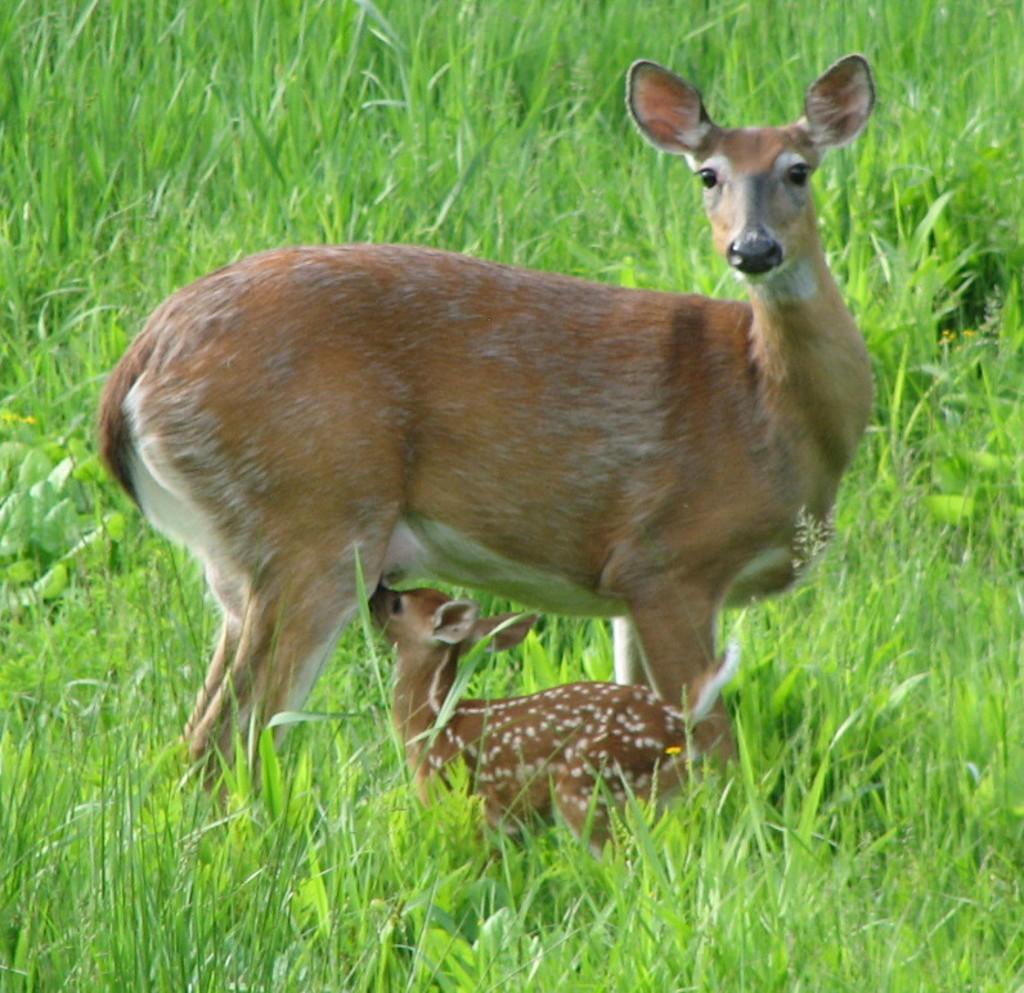Can you describe this image briefly? In this picture, we see deer and fawn. We see grass in the background and this picture might be clicked in a zoo. 